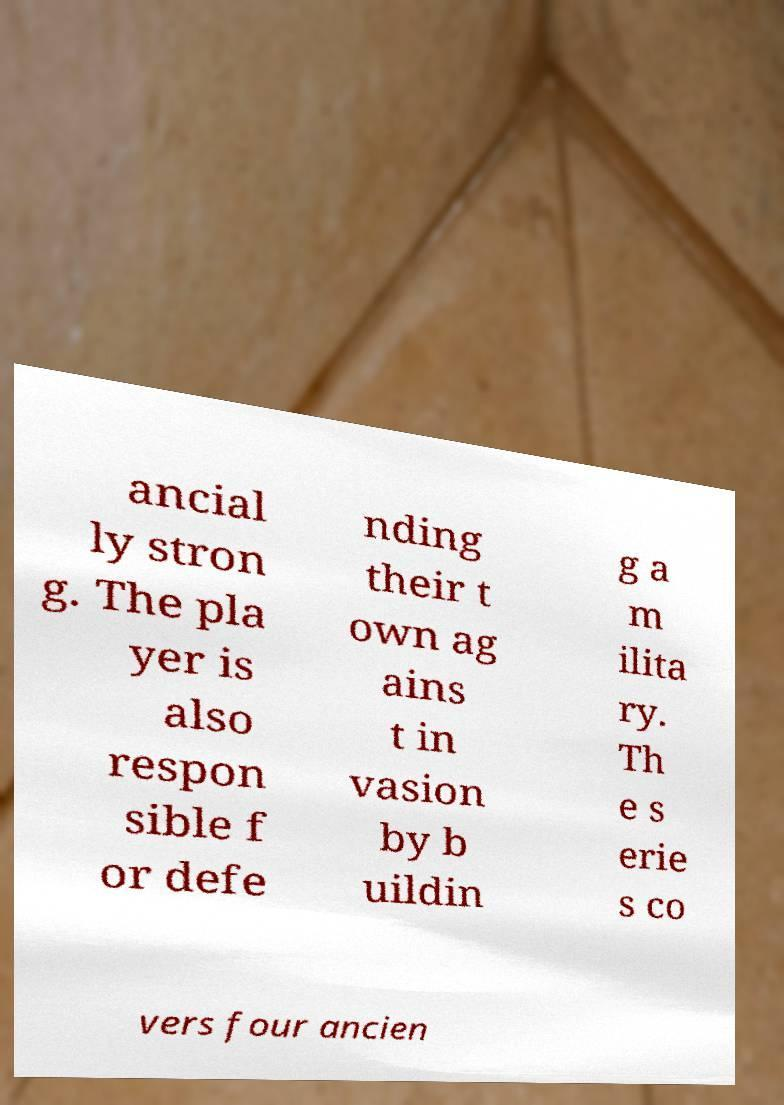Please identify and transcribe the text found in this image. ancial ly stron g. The pla yer is also respon sible f or defe nding their t own ag ains t in vasion by b uildin g a m ilita ry. Th e s erie s co vers four ancien 